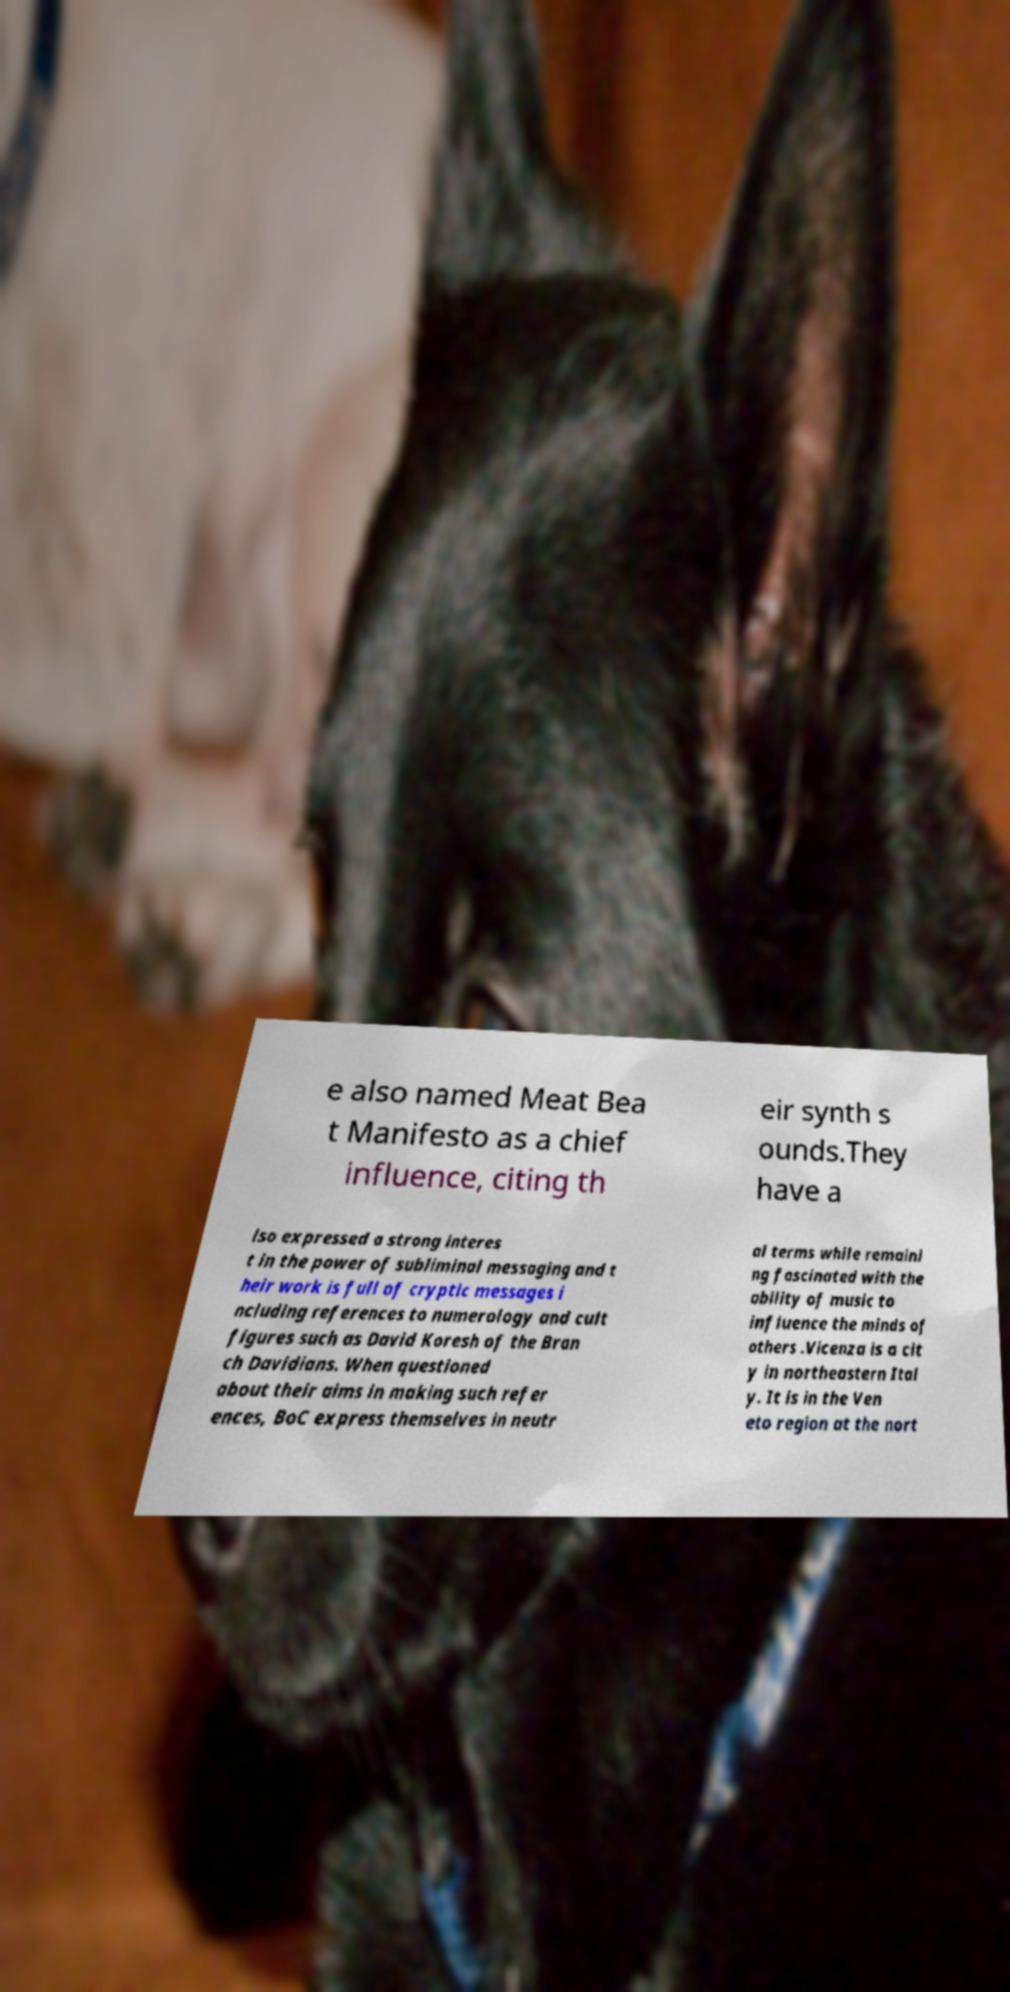I need the written content from this picture converted into text. Can you do that? e also named Meat Bea t Manifesto as a chief influence, citing th eir synth s ounds.They have a lso expressed a strong interes t in the power of subliminal messaging and t heir work is full of cryptic messages i ncluding references to numerology and cult figures such as David Koresh of the Bran ch Davidians. When questioned about their aims in making such refer ences, BoC express themselves in neutr al terms while remaini ng fascinated with the ability of music to influence the minds of others .Vicenza is a cit y in northeastern Ital y. It is in the Ven eto region at the nort 